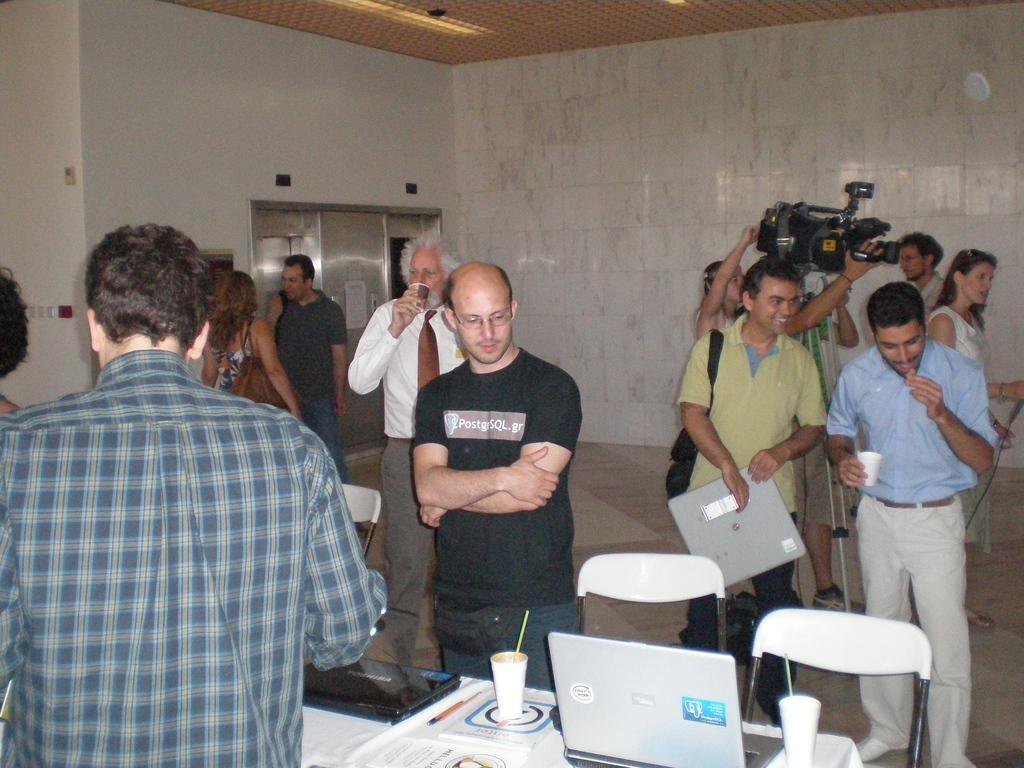How would you summarize this image in a sentence or two? people are standing on the floor. there is a table on which there is laptop, glass, papers. at the back a person is holding a camera. behind him there is a white wall. 